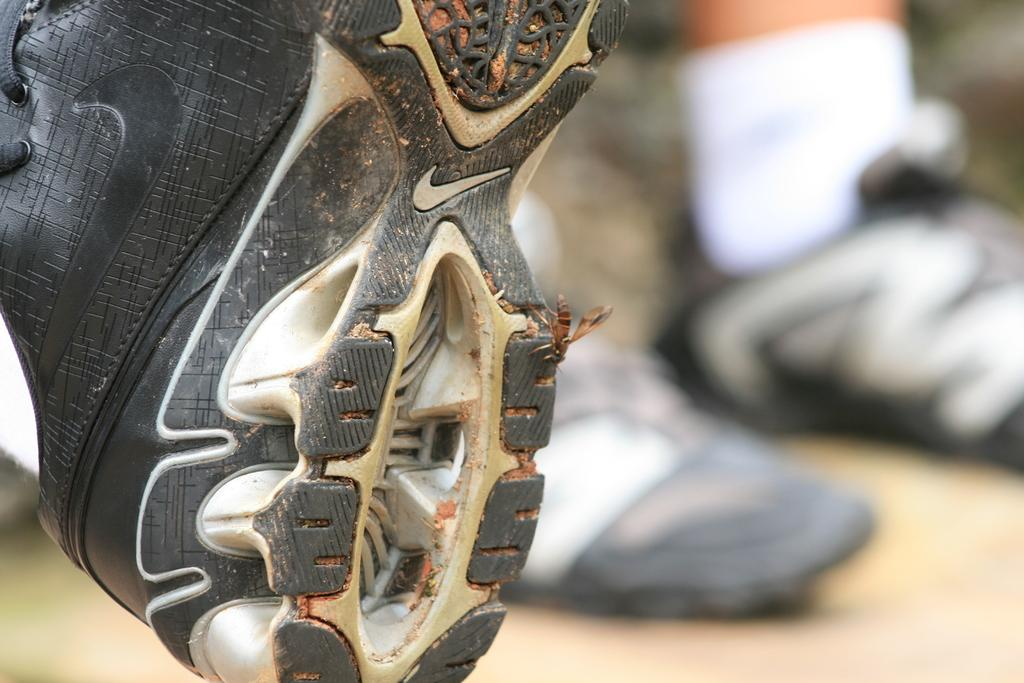What object is the main focus of the image? There is a shoe in the image. Can you see any part of a person in the image? Yes, there is a person's leg visible in the background. What is covering the person's leg? The person's leg has a sock on it. Are there any other shoes visible in the image? Yes, there are shoes on the ground in the background. How would you describe the background of the image? The background is blurry. What type of cow can be seen grazing in the background of the image? There is no cow present in the image; the background is blurry and does not show any animals. 